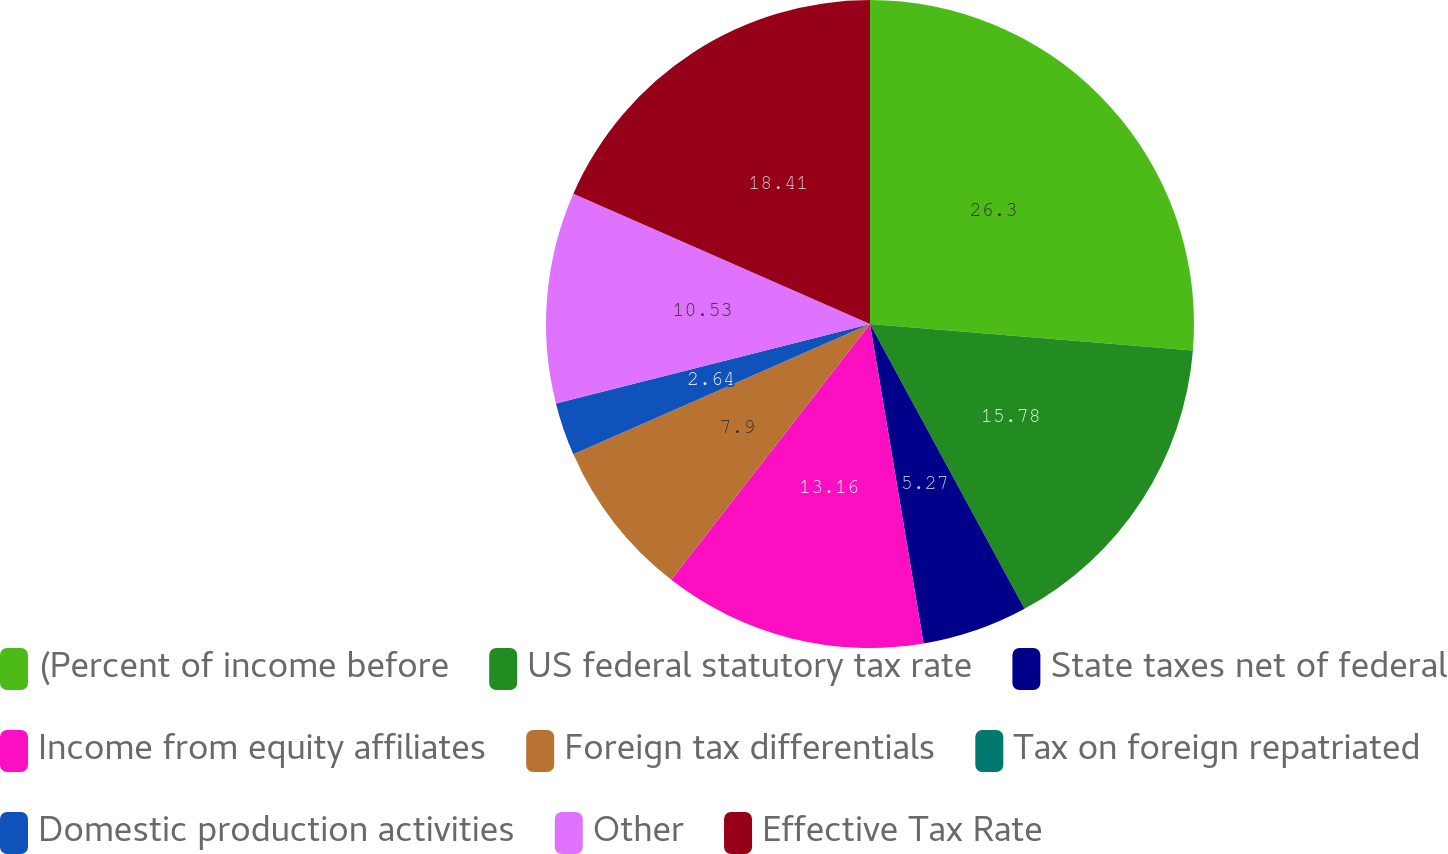Convert chart to OTSL. <chart><loc_0><loc_0><loc_500><loc_500><pie_chart><fcel>(Percent of income before<fcel>US federal statutory tax rate<fcel>State taxes net of federal<fcel>Income from equity affiliates<fcel>Foreign tax differentials<fcel>Tax on foreign repatriated<fcel>Domestic production activities<fcel>Other<fcel>Effective Tax Rate<nl><fcel>26.31%<fcel>15.79%<fcel>5.27%<fcel>13.16%<fcel>7.9%<fcel>0.01%<fcel>2.64%<fcel>10.53%<fcel>18.42%<nl></chart> 